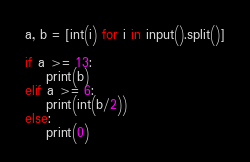<code> <loc_0><loc_0><loc_500><loc_500><_Python_>a, b = [int(i) for i in input().split()]

if a >= 13:
	print(b)
elif a >= 6:
	print(int(b/2))
else:
	print(0)</code> 